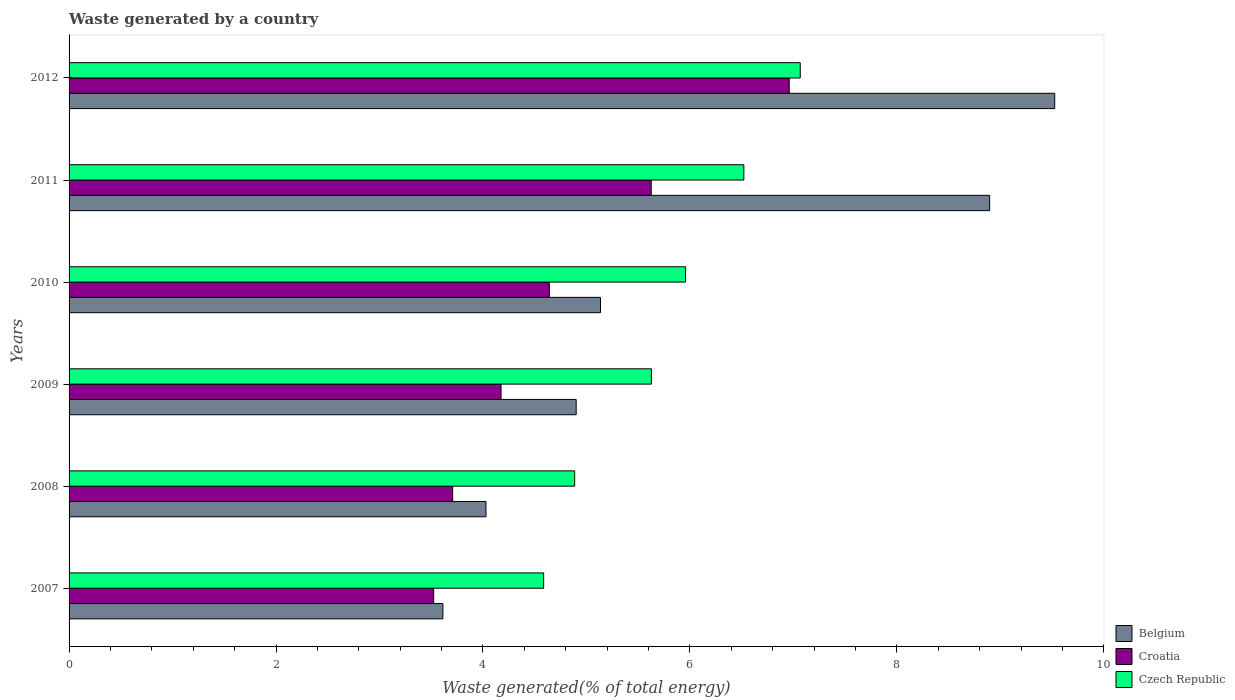How many groups of bars are there?
Make the answer very short. 6. Are the number of bars on each tick of the Y-axis equal?
Ensure brevity in your answer.  Yes. How many bars are there on the 4th tick from the top?
Offer a very short reply. 3. What is the total waste generated in Croatia in 2008?
Keep it short and to the point. 3.71. Across all years, what is the maximum total waste generated in Czech Republic?
Your answer should be very brief. 7.07. Across all years, what is the minimum total waste generated in Belgium?
Make the answer very short. 3.61. In which year was the total waste generated in Croatia maximum?
Keep it short and to the point. 2012. In which year was the total waste generated in Croatia minimum?
Provide a short and direct response. 2007. What is the total total waste generated in Czech Republic in the graph?
Your response must be concise. 34.65. What is the difference between the total waste generated in Croatia in 2007 and that in 2009?
Provide a short and direct response. -0.65. What is the difference between the total waste generated in Croatia in 2011 and the total waste generated in Czech Republic in 2008?
Your answer should be very brief. 0.74. What is the average total waste generated in Croatia per year?
Your response must be concise. 4.77. In the year 2012, what is the difference between the total waste generated in Belgium and total waste generated in Croatia?
Your response must be concise. 2.57. What is the ratio of the total waste generated in Czech Republic in 2009 to that in 2012?
Your answer should be compact. 0.8. Is the total waste generated in Belgium in 2008 less than that in 2012?
Ensure brevity in your answer.  Yes. What is the difference between the highest and the second highest total waste generated in Croatia?
Offer a very short reply. 1.33. What is the difference between the highest and the lowest total waste generated in Croatia?
Your answer should be compact. 3.44. In how many years, is the total waste generated in Czech Republic greater than the average total waste generated in Czech Republic taken over all years?
Ensure brevity in your answer.  3. Is the sum of the total waste generated in Croatia in 2007 and 2008 greater than the maximum total waste generated in Czech Republic across all years?
Offer a very short reply. Yes. What does the 3rd bar from the bottom in 2011 represents?
Ensure brevity in your answer.  Czech Republic. How many bars are there?
Your answer should be very brief. 18. Are the values on the major ticks of X-axis written in scientific E-notation?
Provide a succinct answer. No. Where does the legend appear in the graph?
Make the answer very short. Bottom right. How many legend labels are there?
Offer a very short reply. 3. What is the title of the graph?
Offer a terse response. Waste generated by a country. Does "Djibouti" appear as one of the legend labels in the graph?
Your answer should be very brief. No. What is the label or title of the X-axis?
Your answer should be compact. Waste generated(% of total energy). What is the label or title of the Y-axis?
Offer a very short reply. Years. What is the Waste generated(% of total energy) in Belgium in 2007?
Your answer should be very brief. 3.61. What is the Waste generated(% of total energy) in Croatia in 2007?
Your response must be concise. 3.52. What is the Waste generated(% of total energy) of Czech Republic in 2007?
Ensure brevity in your answer.  4.59. What is the Waste generated(% of total energy) in Belgium in 2008?
Provide a short and direct response. 4.03. What is the Waste generated(% of total energy) of Croatia in 2008?
Make the answer very short. 3.71. What is the Waste generated(% of total energy) of Czech Republic in 2008?
Keep it short and to the point. 4.89. What is the Waste generated(% of total energy) in Belgium in 2009?
Your answer should be compact. 4.9. What is the Waste generated(% of total energy) of Croatia in 2009?
Your response must be concise. 4.17. What is the Waste generated(% of total energy) in Czech Republic in 2009?
Offer a very short reply. 5.63. What is the Waste generated(% of total energy) of Belgium in 2010?
Provide a succinct answer. 5.14. What is the Waste generated(% of total energy) of Croatia in 2010?
Offer a terse response. 4.64. What is the Waste generated(% of total energy) of Czech Republic in 2010?
Give a very brief answer. 5.96. What is the Waste generated(% of total energy) of Belgium in 2011?
Your response must be concise. 8.9. What is the Waste generated(% of total energy) of Croatia in 2011?
Keep it short and to the point. 5.63. What is the Waste generated(% of total energy) of Czech Republic in 2011?
Ensure brevity in your answer.  6.52. What is the Waste generated(% of total energy) in Belgium in 2012?
Offer a very short reply. 9.53. What is the Waste generated(% of total energy) of Croatia in 2012?
Ensure brevity in your answer.  6.96. What is the Waste generated(% of total energy) of Czech Republic in 2012?
Provide a short and direct response. 7.07. Across all years, what is the maximum Waste generated(% of total energy) of Belgium?
Offer a very short reply. 9.53. Across all years, what is the maximum Waste generated(% of total energy) of Croatia?
Your answer should be compact. 6.96. Across all years, what is the maximum Waste generated(% of total energy) in Czech Republic?
Your answer should be very brief. 7.07. Across all years, what is the minimum Waste generated(% of total energy) in Belgium?
Give a very brief answer. 3.61. Across all years, what is the minimum Waste generated(% of total energy) of Croatia?
Offer a very short reply. 3.52. Across all years, what is the minimum Waste generated(% of total energy) in Czech Republic?
Provide a short and direct response. 4.59. What is the total Waste generated(% of total energy) of Belgium in the graph?
Offer a very short reply. 36.1. What is the total Waste generated(% of total energy) in Croatia in the graph?
Keep it short and to the point. 28.63. What is the total Waste generated(% of total energy) in Czech Republic in the graph?
Ensure brevity in your answer.  34.65. What is the difference between the Waste generated(% of total energy) of Belgium in 2007 and that in 2008?
Your answer should be very brief. -0.42. What is the difference between the Waste generated(% of total energy) in Croatia in 2007 and that in 2008?
Ensure brevity in your answer.  -0.18. What is the difference between the Waste generated(% of total energy) in Czech Republic in 2007 and that in 2008?
Make the answer very short. -0.3. What is the difference between the Waste generated(% of total energy) of Belgium in 2007 and that in 2009?
Ensure brevity in your answer.  -1.29. What is the difference between the Waste generated(% of total energy) of Croatia in 2007 and that in 2009?
Keep it short and to the point. -0.65. What is the difference between the Waste generated(% of total energy) of Czech Republic in 2007 and that in 2009?
Provide a succinct answer. -1.04. What is the difference between the Waste generated(% of total energy) in Belgium in 2007 and that in 2010?
Keep it short and to the point. -1.52. What is the difference between the Waste generated(% of total energy) in Croatia in 2007 and that in 2010?
Provide a short and direct response. -1.12. What is the difference between the Waste generated(% of total energy) in Czech Republic in 2007 and that in 2010?
Offer a very short reply. -1.37. What is the difference between the Waste generated(% of total energy) in Belgium in 2007 and that in 2011?
Your response must be concise. -5.28. What is the difference between the Waste generated(% of total energy) of Croatia in 2007 and that in 2011?
Your answer should be compact. -2.1. What is the difference between the Waste generated(% of total energy) of Czech Republic in 2007 and that in 2011?
Your answer should be very brief. -1.93. What is the difference between the Waste generated(% of total energy) of Belgium in 2007 and that in 2012?
Your answer should be very brief. -5.91. What is the difference between the Waste generated(% of total energy) of Croatia in 2007 and that in 2012?
Your response must be concise. -3.44. What is the difference between the Waste generated(% of total energy) in Czech Republic in 2007 and that in 2012?
Ensure brevity in your answer.  -2.48. What is the difference between the Waste generated(% of total energy) in Belgium in 2008 and that in 2009?
Offer a terse response. -0.87. What is the difference between the Waste generated(% of total energy) of Croatia in 2008 and that in 2009?
Your answer should be compact. -0.47. What is the difference between the Waste generated(% of total energy) of Czech Republic in 2008 and that in 2009?
Offer a terse response. -0.74. What is the difference between the Waste generated(% of total energy) in Belgium in 2008 and that in 2010?
Offer a very short reply. -1.11. What is the difference between the Waste generated(% of total energy) in Croatia in 2008 and that in 2010?
Your response must be concise. -0.93. What is the difference between the Waste generated(% of total energy) of Czech Republic in 2008 and that in 2010?
Make the answer very short. -1.07. What is the difference between the Waste generated(% of total energy) in Belgium in 2008 and that in 2011?
Offer a very short reply. -4.87. What is the difference between the Waste generated(% of total energy) of Croatia in 2008 and that in 2011?
Offer a very short reply. -1.92. What is the difference between the Waste generated(% of total energy) of Czech Republic in 2008 and that in 2011?
Your answer should be very brief. -1.64. What is the difference between the Waste generated(% of total energy) in Belgium in 2008 and that in 2012?
Offer a terse response. -5.5. What is the difference between the Waste generated(% of total energy) of Croatia in 2008 and that in 2012?
Provide a short and direct response. -3.25. What is the difference between the Waste generated(% of total energy) in Czech Republic in 2008 and that in 2012?
Offer a very short reply. -2.18. What is the difference between the Waste generated(% of total energy) in Belgium in 2009 and that in 2010?
Your response must be concise. -0.24. What is the difference between the Waste generated(% of total energy) in Croatia in 2009 and that in 2010?
Provide a succinct answer. -0.47. What is the difference between the Waste generated(% of total energy) of Czech Republic in 2009 and that in 2010?
Your answer should be compact. -0.33. What is the difference between the Waste generated(% of total energy) of Belgium in 2009 and that in 2011?
Make the answer very short. -4. What is the difference between the Waste generated(% of total energy) in Croatia in 2009 and that in 2011?
Your answer should be compact. -1.45. What is the difference between the Waste generated(% of total energy) in Czech Republic in 2009 and that in 2011?
Provide a succinct answer. -0.89. What is the difference between the Waste generated(% of total energy) in Belgium in 2009 and that in 2012?
Your response must be concise. -4.62. What is the difference between the Waste generated(% of total energy) of Croatia in 2009 and that in 2012?
Make the answer very short. -2.79. What is the difference between the Waste generated(% of total energy) of Czech Republic in 2009 and that in 2012?
Make the answer very short. -1.44. What is the difference between the Waste generated(% of total energy) in Belgium in 2010 and that in 2011?
Provide a short and direct response. -3.76. What is the difference between the Waste generated(% of total energy) in Croatia in 2010 and that in 2011?
Your answer should be compact. -0.98. What is the difference between the Waste generated(% of total energy) of Czech Republic in 2010 and that in 2011?
Give a very brief answer. -0.56. What is the difference between the Waste generated(% of total energy) of Belgium in 2010 and that in 2012?
Your answer should be compact. -4.39. What is the difference between the Waste generated(% of total energy) of Croatia in 2010 and that in 2012?
Keep it short and to the point. -2.32. What is the difference between the Waste generated(% of total energy) in Czech Republic in 2010 and that in 2012?
Ensure brevity in your answer.  -1.11. What is the difference between the Waste generated(% of total energy) in Belgium in 2011 and that in 2012?
Your response must be concise. -0.63. What is the difference between the Waste generated(% of total energy) in Croatia in 2011 and that in 2012?
Your answer should be very brief. -1.33. What is the difference between the Waste generated(% of total energy) of Czech Republic in 2011 and that in 2012?
Make the answer very short. -0.54. What is the difference between the Waste generated(% of total energy) in Belgium in 2007 and the Waste generated(% of total energy) in Croatia in 2008?
Your answer should be compact. -0.09. What is the difference between the Waste generated(% of total energy) in Belgium in 2007 and the Waste generated(% of total energy) in Czech Republic in 2008?
Provide a short and direct response. -1.27. What is the difference between the Waste generated(% of total energy) in Croatia in 2007 and the Waste generated(% of total energy) in Czech Republic in 2008?
Your answer should be compact. -1.36. What is the difference between the Waste generated(% of total energy) of Belgium in 2007 and the Waste generated(% of total energy) of Croatia in 2009?
Give a very brief answer. -0.56. What is the difference between the Waste generated(% of total energy) of Belgium in 2007 and the Waste generated(% of total energy) of Czech Republic in 2009?
Ensure brevity in your answer.  -2.02. What is the difference between the Waste generated(% of total energy) of Croatia in 2007 and the Waste generated(% of total energy) of Czech Republic in 2009?
Provide a succinct answer. -2.1. What is the difference between the Waste generated(% of total energy) in Belgium in 2007 and the Waste generated(% of total energy) in Croatia in 2010?
Your response must be concise. -1.03. What is the difference between the Waste generated(% of total energy) in Belgium in 2007 and the Waste generated(% of total energy) in Czech Republic in 2010?
Offer a very short reply. -2.35. What is the difference between the Waste generated(% of total energy) in Croatia in 2007 and the Waste generated(% of total energy) in Czech Republic in 2010?
Offer a terse response. -2.43. What is the difference between the Waste generated(% of total energy) in Belgium in 2007 and the Waste generated(% of total energy) in Croatia in 2011?
Offer a terse response. -2.01. What is the difference between the Waste generated(% of total energy) of Belgium in 2007 and the Waste generated(% of total energy) of Czech Republic in 2011?
Provide a succinct answer. -2.91. What is the difference between the Waste generated(% of total energy) of Croatia in 2007 and the Waste generated(% of total energy) of Czech Republic in 2011?
Your answer should be very brief. -3. What is the difference between the Waste generated(% of total energy) of Belgium in 2007 and the Waste generated(% of total energy) of Croatia in 2012?
Your response must be concise. -3.35. What is the difference between the Waste generated(% of total energy) of Belgium in 2007 and the Waste generated(% of total energy) of Czech Republic in 2012?
Your response must be concise. -3.45. What is the difference between the Waste generated(% of total energy) in Croatia in 2007 and the Waste generated(% of total energy) in Czech Republic in 2012?
Ensure brevity in your answer.  -3.54. What is the difference between the Waste generated(% of total energy) in Belgium in 2008 and the Waste generated(% of total energy) in Croatia in 2009?
Give a very brief answer. -0.15. What is the difference between the Waste generated(% of total energy) in Belgium in 2008 and the Waste generated(% of total energy) in Czech Republic in 2009?
Make the answer very short. -1.6. What is the difference between the Waste generated(% of total energy) in Croatia in 2008 and the Waste generated(% of total energy) in Czech Republic in 2009?
Keep it short and to the point. -1.92. What is the difference between the Waste generated(% of total energy) of Belgium in 2008 and the Waste generated(% of total energy) of Croatia in 2010?
Keep it short and to the point. -0.61. What is the difference between the Waste generated(% of total energy) of Belgium in 2008 and the Waste generated(% of total energy) of Czech Republic in 2010?
Give a very brief answer. -1.93. What is the difference between the Waste generated(% of total energy) of Croatia in 2008 and the Waste generated(% of total energy) of Czech Republic in 2010?
Your answer should be very brief. -2.25. What is the difference between the Waste generated(% of total energy) in Belgium in 2008 and the Waste generated(% of total energy) in Croatia in 2011?
Your response must be concise. -1.6. What is the difference between the Waste generated(% of total energy) in Belgium in 2008 and the Waste generated(% of total energy) in Czech Republic in 2011?
Keep it short and to the point. -2.49. What is the difference between the Waste generated(% of total energy) of Croatia in 2008 and the Waste generated(% of total energy) of Czech Republic in 2011?
Give a very brief answer. -2.81. What is the difference between the Waste generated(% of total energy) in Belgium in 2008 and the Waste generated(% of total energy) in Croatia in 2012?
Make the answer very short. -2.93. What is the difference between the Waste generated(% of total energy) in Belgium in 2008 and the Waste generated(% of total energy) in Czech Republic in 2012?
Give a very brief answer. -3.04. What is the difference between the Waste generated(% of total energy) in Croatia in 2008 and the Waste generated(% of total energy) in Czech Republic in 2012?
Offer a very short reply. -3.36. What is the difference between the Waste generated(% of total energy) in Belgium in 2009 and the Waste generated(% of total energy) in Croatia in 2010?
Provide a succinct answer. 0.26. What is the difference between the Waste generated(% of total energy) of Belgium in 2009 and the Waste generated(% of total energy) of Czech Republic in 2010?
Your answer should be compact. -1.06. What is the difference between the Waste generated(% of total energy) in Croatia in 2009 and the Waste generated(% of total energy) in Czech Republic in 2010?
Keep it short and to the point. -1.78. What is the difference between the Waste generated(% of total energy) of Belgium in 2009 and the Waste generated(% of total energy) of Croatia in 2011?
Offer a terse response. -0.73. What is the difference between the Waste generated(% of total energy) in Belgium in 2009 and the Waste generated(% of total energy) in Czech Republic in 2011?
Keep it short and to the point. -1.62. What is the difference between the Waste generated(% of total energy) in Croatia in 2009 and the Waste generated(% of total energy) in Czech Republic in 2011?
Keep it short and to the point. -2.35. What is the difference between the Waste generated(% of total energy) of Belgium in 2009 and the Waste generated(% of total energy) of Croatia in 2012?
Ensure brevity in your answer.  -2.06. What is the difference between the Waste generated(% of total energy) of Belgium in 2009 and the Waste generated(% of total energy) of Czech Republic in 2012?
Ensure brevity in your answer.  -2.17. What is the difference between the Waste generated(% of total energy) in Croatia in 2009 and the Waste generated(% of total energy) in Czech Republic in 2012?
Provide a short and direct response. -2.89. What is the difference between the Waste generated(% of total energy) in Belgium in 2010 and the Waste generated(% of total energy) in Croatia in 2011?
Offer a terse response. -0.49. What is the difference between the Waste generated(% of total energy) of Belgium in 2010 and the Waste generated(% of total energy) of Czech Republic in 2011?
Provide a short and direct response. -1.39. What is the difference between the Waste generated(% of total energy) in Croatia in 2010 and the Waste generated(% of total energy) in Czech Republic in 2011?
Offer a terse response. -1.88. What is the difference between the Waste generated(% of total energy) in Belgium in 2010 and the Waste generated(% of total energy) in Croatia in 2012?
Offer a terse response. -1.82. What is the difference between the Waste generated(% of total energy) in Belgium in 2010 and the Waste generated(% of total energy) in Czech Republic in 2012?
Ensure brevity in your answer.  -1.93. What is the difference between the Waste generated(% of total energy) in Croatia in 2010 and the Waste generated(% of total energy) in Czech Republic in 2012?
Give a very brief answer. -2.42. What is the difference between the Waste generated(% of total energy) of Belgium in 2011 and the Waste generated(% of total energy) of Croatia in 2012?
Your answer should be very brief. 1.94. What is the difference between the Waste generated(% of total energy) in Belgium in 2011 and the Waste generated(% of total energy) in Czech Republic in 2012?
Offer a terse response. 1.83. What is the difference between the Waste generated(% of total energy) in Croatia in 2011 and the Waste generated(% of total energy) in Czech Republic in 2012?
Give a very brief answer. -1.44. What is the average Waste generated(% of total energy) of Belgium per year?
Your response must be concise. 6.02. What is the average Waste generated(% of total energy) in Croatia per year?
Keep it short and to the point. 4.77. What is the average Waste generated(% of total energy) in Czech Republic per year?
Offer a very short reply. 5.77. In the year 2007, what is the difference between the Waste generated(% of total energy) in Belgium and Waste generated(% of total energy) in Croatia?
Ensure brevity in your answer.  0.09. In the year 2007, what is the difference between the Waste generated(% of total energy) in Belgium and Waste generated(% of total energy) in Czech Republic?
Your answer should be compact. -0.97. In the year 2007, what is the difference between the Waste generated(% of total energy) in Croatia and Waste generated(% of total energy) in Czech Republic?
Your response must be concise. -1.06. In the year 2008, what is the difference between the Waste generated(% of total energy) of Belgium and Waste generated(% of total energy) of Croatia?
Provide a succinct answer. 0.32. In the year 2008, what is the difference between the Waste generated(% of total energy) of Belgium and Waste generated(% of total energy) of Czech Republic?
Offer a very short reply. -0.86. In the year 2008, what is the difference between the Waste generated(% of total energy) in Croatia and Waste generated(% of total energy) in Czech Republic?
Provide a succinct answer. -1.18. In the year 2009, what is the difference between the Waste generated(% of total energy) of Belgium and Waste generated(% of total energy) of Croatia?
Offer a very short reply. 0.73. In the year 2009, what is the difference between the Waste generated(% of total energy) of Belgium and Waste generated(% of total energy) of Czech Republic?
Make the answer very short. -0.73. In the year 2009, what is the difference between the Waste generated(% of total energy) in Croatia and Waste generated(% of total energy) in Czech Republic?
Offer a very short reply. -1.45. In the year 2010, what is the difference between the Waste generated(% of total energy) in Belgium and Waste generated(% of total energy) in Croatia?
Your answer should be very brief. 0.49. In the year 2010, what is the difference between the Waste generated(% of total energy) of Belgium and Waste generated(% of total energy) of Czech Republic?
Make the answer very short. -0.82. In the year 2010, what is the difference between the Waste generated(% of total energy) in Croatia and Waste generated(% of total energy) in Czech Republic?
Provide a short and direct response. -1.32. In the year 2011, what is the difference between the Waste generated(% of total energy) in Belgium and Waste generated(% of total energy) in Croatia?
Make the answer very short. 3.27. In the year 2011, what is the difference between the Waste generated(% of total energy) of Belgium and Waste generated(% of total energy) of Czech Republic?
Your answer should be very brief. 2.38. In the year 2011, what is the difference between the Waste generated(% of total energy) of Croatia and Waste generated(% of total energy) of Czech Republic?
Your response must be concise. -0.9. In the year 2012, what is the difference between the Waste generated(% of total energy) of Belgium and Waste generated(% of total energy) of Croatia?
Your response must be concise. 2.57. In the year 2012, what is the difference between the Waste generated(% of total energy) of Belgium and Waste generated(% of total energy) of Czech Republic?
Your answer should be compact. 2.46. In the year 2012, what is the difference between the Waste generated(% of total energy) of Croatia and Waste generated(% of total energy) of Czech Republic?
Provide a short and direct response. -0.11. What is the ratio of the Waste generated(% of total energy) in Belgium in 2007 to that in 2008?
Ensure brevity in your answer.  0.9. What is the ratio of the Waste generated(% of total energy) in Croatia in 2007 to that in 2008?
Your response must be concise. 0.95. What is the ratio of the Waste generated(% of total energy) of Czech Republic in 2007 to that in 2008?
Your answer should be very brief. 0.94. What is the ratio of the Waste generated(% of total energy) of Belgium in 2007 to that in 2009?
Keep it short and to the point. 0.74. What is the ratio of the Waste generated(% of total energy) in Croatia in 2007 to that in 2009?
Your answer should be compact. 0.84. What is the ratio of the Waste generated(% of total energy) of Czech Republic in 2007 to that in 2009?
Your answer should be very brief. 0.81. What is the ratio of the Waste generated(% of total energy) of Belgium in 2007 to that in 2010?
Your answer should be compact. 0.7. What is the ratio of the Waste generated(% of total energy) in Croatia in 2007 to that in 2010?
Give a very brief answer. 0.76. What is the ratio of the Waste generated(% of total energy) in Czech Republic in 2007 to that in 2010?
Give a very brief answer. 0.77. What is the ratio of the Waste generated(% of total energy) in Belgium in 2007 to that in 2011?
Keep it short and to the point. 0.41. What is the ratio of the Waste generated(% of total energy) of Croatia in 2007 to that in 2011?
Your answer should be very brief. 0.63. What is the ratio of the Waste generated(% of total energy) in Czech Republic in 2007 to that in 2011?
Keep it short and to the point. 0.7. What is the ratio of the Waste generated(% of total energy) in Belgium in 2007 to that in 2012?
Your response must be concise. 0.38. What is the ratio of the Waste generated(% of total energy) in Croatia in 2007 to that in 2012?
Ensure brevity in your answer.  0.51. What is the ratio of the Waste generated(% of total energy) in Czech Republic in 2007 to that in 2012?
Make the answer very short. 0.65. What is the ratio of the Waste generated(% of total energy) in Belgium in 2008 to that in 2009?
Offer a terse response. 0.82. What is the ratio of the Waste generated(% of total energy) of Croatia in 2008 to that in 2009?
Provide a short and direct response. 0.89. What is the ratio of the Waste generated(% of total energy) of Czech Republic in 2008 to that in 2009?
Keep it short and to the point. 0.87. What is the ratio of the Waste generated(% of total energy) of Belgium in 2008 to that in 2010?
Give a very brief answer. 0.78. What is the ratio of the Waste generated(% of total energy) in Croatia in 2008 to that in 2010?
Ensure brevity in your answer.  0.8. What is the ratio of the Waste generated(% of total energy) of Czech Republic in 2008 to that in 2010?
Your answer should be very brief. 0.82. What is the ratio of the Waste generated(% of total energy) of Belgium in 2008 to that in 2011?
Make the answer very short. 0.45. What is the ratio of the Waste generated(% of total energy) in Croatia in 2008 to that in 2011?
Your answer should be compact. 0.66. What is the ratio of the Waste generated(% of total energy) in Czech Republic in 2008 to that in 2011?
Your answer should be compact. 0.75. What is the ratio of the Waste generated(% of total energy) in Belgium in 2008 to that in 2012?
Make the answer very short. 0.42. What is the ratio of the Waste generated(% of total energy) of Croatia in 2008 to that in 2012?
Your answer should be very brief. 0.53. What is the ratio of the Waste generated(% of total energy) of Czech Republic in 2008 to that in 2012?
Your answer should be very brief. 0.69. What is the ratio of the Waste generated(% of total energy) of Belgium in 2009 to that in 2010?
Ensure brevity in your answer.  0.95. What is the ratio of the Waste generated(% of total energy) in Croatia in 2009 to that in 2010?
Your answer should be very brief. 0.9. What is the ratio of the Waste generated(% of total energy) of Czech Republic in 2009 to that in 2010?
Give a very brief answer. 0.94. What is the ratio of the Waste generated(% of total energy) in Belgium in 2009 to that in 2011?
Make the answer very short. 0.55. What is the ratio of the Waste generated(% of total energy) of Croatia in 2009 to that in 2011?
Offer a terse response. 0.74. What is the ratio of the Waste generated(% of total energy) in Czech Republic in 2009 to that in 2011?
Give a very brief answer. 0.86. What is the ratio of the Waste generated(% of total energy) in Belgium in 2009 to that in 2012?
Your answer should be compact. 0.51. What is the ratio of the Waste generated(% of total energy) in Croatia in 2009 to that in 2012?
Give a very brief answer. 0.6. What is the ratio of the Waste generated(% of total energy) in Czech Republic in 2009 to that in 2012?
Offer a terse response. 0.8. What is the ratio of the Waste generated(% of total energy) in Belgium in 2010 to that in 2011?
Make the answer very short. 0.58. What is the ratio of the Waste generated(% of total energy) in Croatia in 2010 to that in 2011?
Your answer should be compact. 0.82. What is the ratio of the Waste generated(% of total energy) in Czech Republic in 2010 to that in 2011?
Offer a terse response. 0.91. What is the ratio of the Waste generated(% of total energy) in Belgium in 2010 to that in 2012?
Your response must be concise. 0.54. What is the ratio of the Waste generated(% of total energy) in Croatia in 2010 to that in 2012?
Give a very brief answer. 0.67. What is the ratio of the Waste generated(% of total energy) in Czech Republic in 2010 to that in 2012?
Offer a terse response. 0.84. What is the ratio of the Waste generated(% of total energy) in Belgium in 2011 to that in 2012?
Your response must be concise. 0.93. What is the ratio of the Waste generated(% of total energy) of Croatia in 2011 to that in 2012?
Give a very brief answer. 0.81. What is the ratio of the Waste generated(% of total energy) of Czech Republic in 2011 to that in 2012?
Give a very brief answer. 0.92. What is the difference between the highest and the second highest Waste generated(% of total energy) of Belgium?
Your answer should be compact. 0.63. What is the difference between the highest and the second highest Waste generated(% of total energy) of Croatia?
Give a very brief answer. 1.33. What is the difference between the highest and the second highest Waste generated(% of total energy) of Czech Republic?
Make the answer very short. 0.54. What is the difference between the highest and the lowest Waste generated(% of total energy) of Belgium?
Your answer should be very brief. 5.91. What is the difference between the highest and the lowest Waste generated(% of total energy) of Croatia?
Provide a succinct answer. 3.44. What is the difference between the highest and the lowest Waste generated(% of total energy) in Czech Republic?
Offer a very short reply. 2.48. 